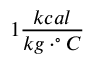Convert formula to latex. <formula><loc_0><loc_0><loc_500><loc_500>1 \frac { k c a l } { k g \cdot ^ { \circ } C }</formula> 